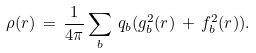<formula> <loc_0><loc_0><loc_500><loc_500>\rho ( r ) \, = \, \frac { 1 } { 4 \pi } \sum _ { b } \, q _ { b } ( g _ { b } ^ { 2 } ( r ) \, + \, f _ { b } ^ { 2 } ( r ) ) .</formula> 